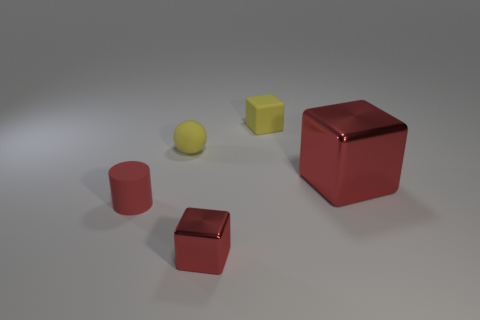What is the arrangement of objects and does it suggest any particular pattern or composition? The arrangement of the objects seems random, with no apparent pattern or deliberate composition. They are spaced out across a flat surface, with various shapes and sizes, implying a casual or natural placement rather than a constructed scene. 